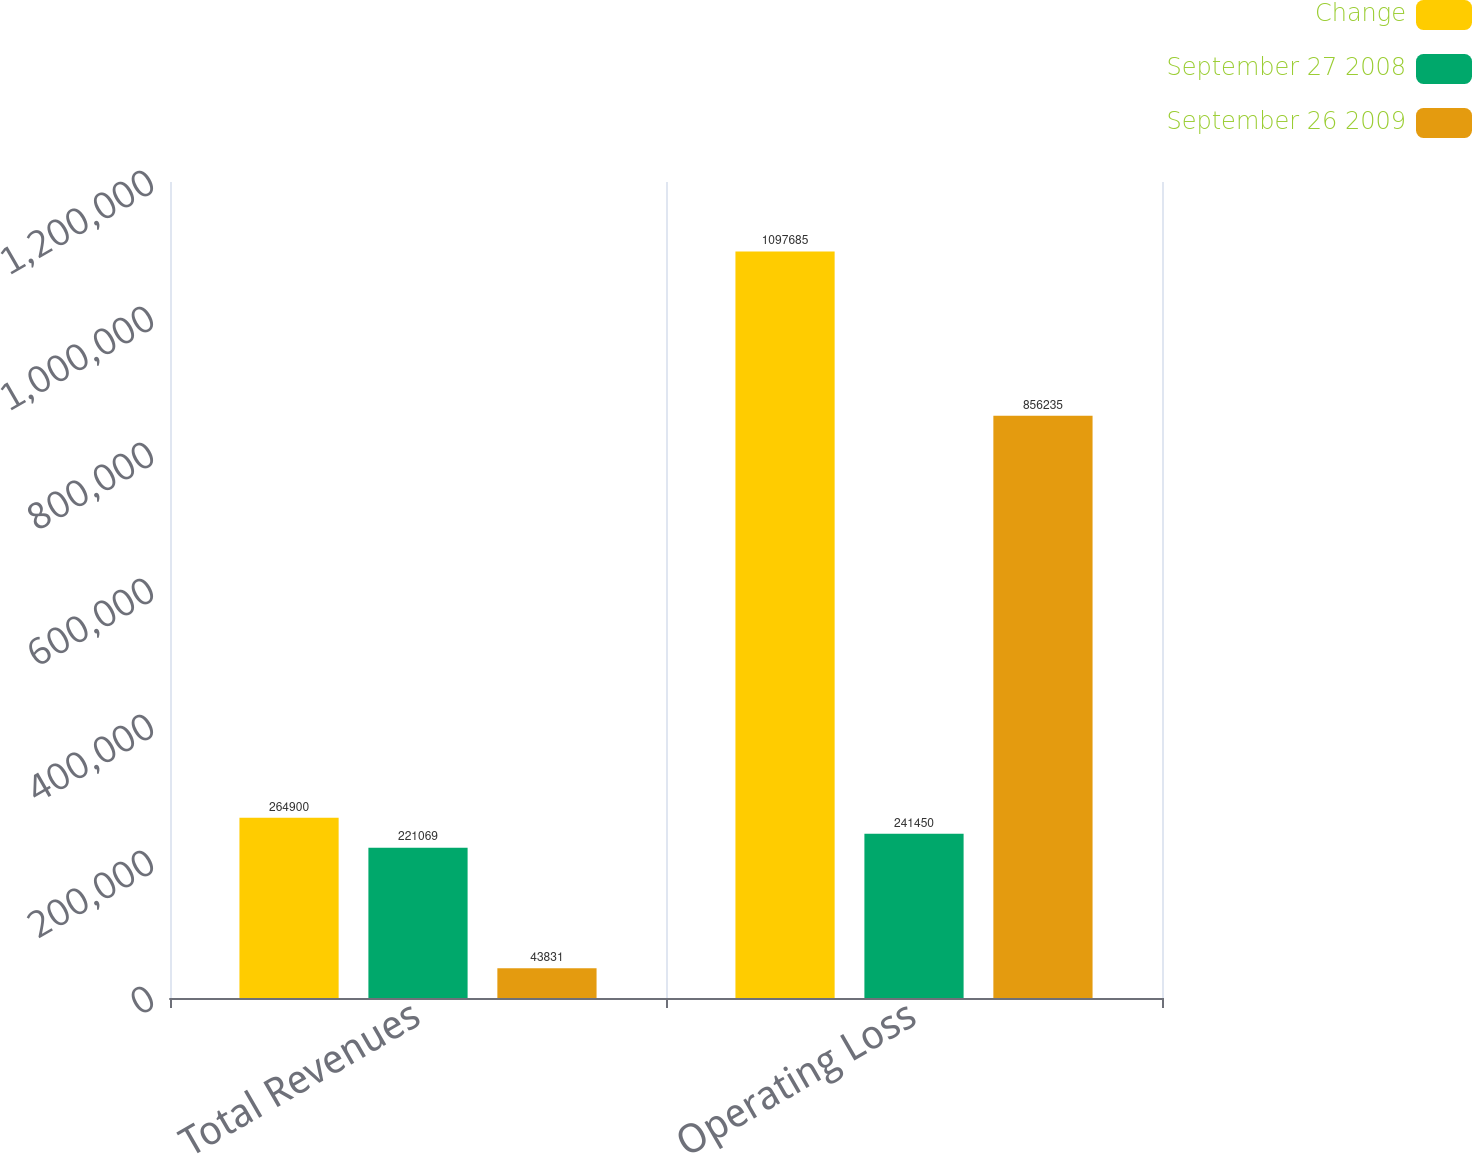Convert chart to OTSL. <chart><loc_0><loc_0><loc_500><loc_500><stacked_bar_chart><ecel><fcel>Total Revenues<fcel>Operating Loss<nl><fcel>Change<fcel>264900<fcel>1.09768e+06<nl><fcel>September 27 2008<fcel>221069<fcel>241450<nl><fcel>September 26 2009<fcel>43831<fcel>856235<nl></chart> 